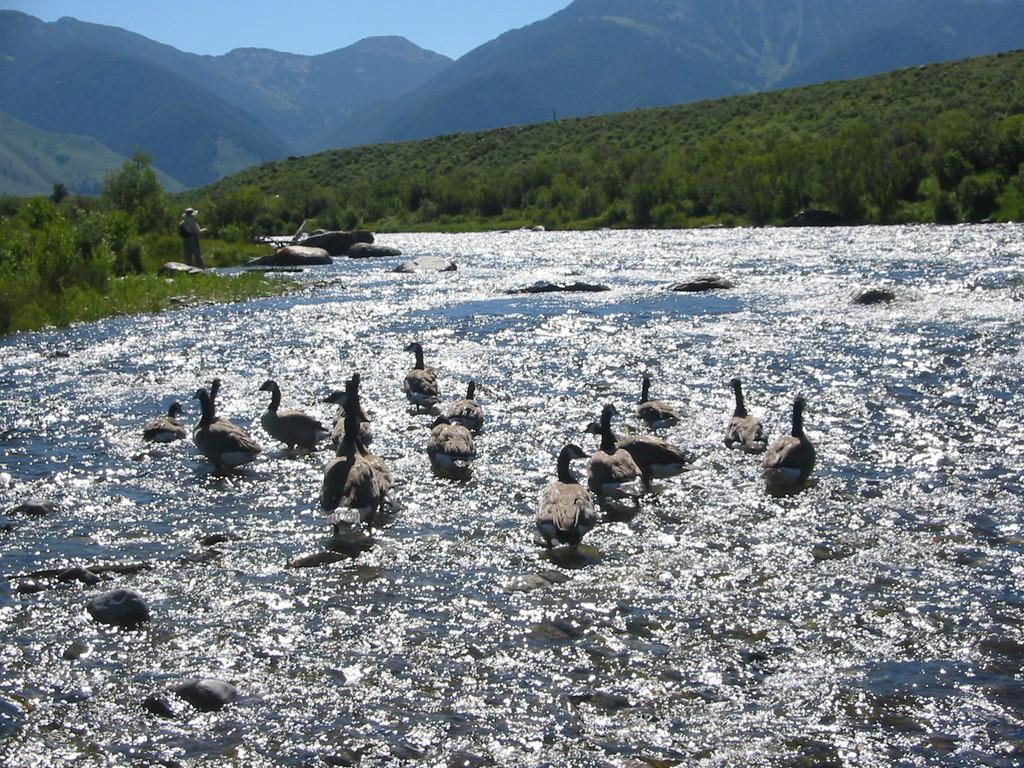What type of natural elements can be seen in the image? There are rocks, ducks in the water, trees, plants, and mountains visible in the image. Can you describe the person in the image? There is a person standing in the image. What is visible in the background of the image? The sky is visible in the background of the image. What type of paste is being used by the ducks in the image? There is no paste present in the image; the ducks are in the water. What fact is being debated by the rocks in the image? There is no debate or fact being discussed by the rocks in the image; they are simply natural elements in the scene. 